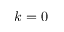<formula> <loc_0><loc_0><loc_500><loc_500>k = 0</formula> 